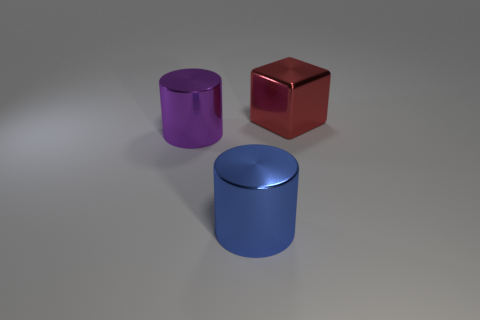Subtract all purple cylinders. How many cylinders are left? 1 Add 3 large green metallic spheres. How many objects exist? 6 Subtract all cylinders. How many objects are left? 1 Subtract all big objects. Subtract all green rubber cylinders. How many objects are left? 0 Add 3 blue metal cylinders. How many blue metal cylinders are left? 4 Add 3 red objects. How many red objects exist? 4 Subtract 0 yellow balls. How many objects are left? 3 